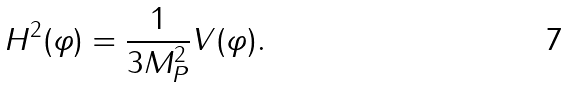Convert formula to latex. <formula><loc_0><loc_0><loc_500><loc_500>H ^ { 2 } ( \varphi ) = \frac { 1 } { 3 M _ { P } ^ { 2 } } V ( \varphi ) .</formula> 